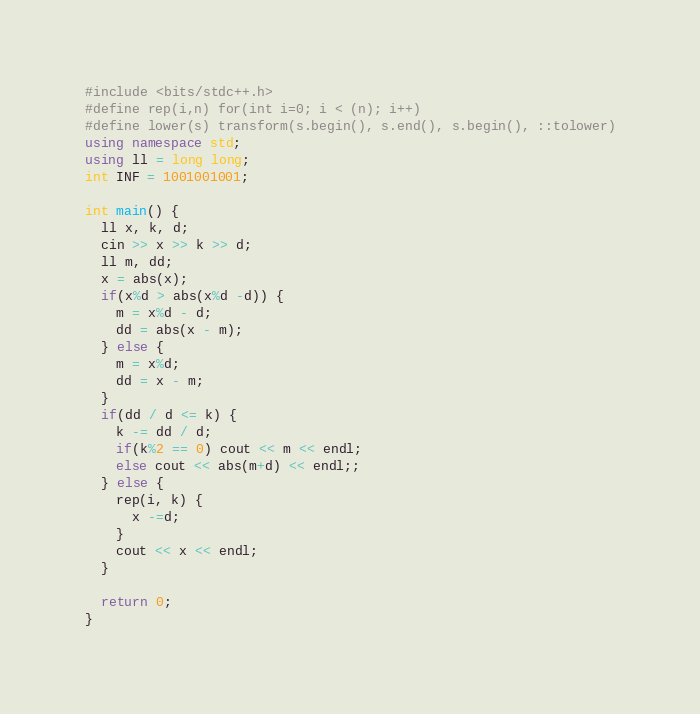Convert code to text. <code><loc_0><loc_0><loc_500><loc_500><_C++_>#include <bits/stdc++.h>
#define rep(i,n) for(int i=0; i < (n); i++)
#define lower(s) transform(s.begin(), s.end(), s.begin(), ::tolower)
using namespace std;
using ll = long long;
int INF = 1001001001;

int main() {
  ll x, k, d;
  cin >> x >> k >> d;
  ll m, dd;
  x = abs(x);
  if(x%d > abs(x%d -d)) {
    m = x%d - d;
    dd = abs(x - m);
  } else {
    m = x%d;
    dd = x - m;
  }
  if(dd / d <= k) {
    k -= dd / d;
    if(k%2 == 0) cout << m << endl;
    else cout << abs(m+d) << endl;;
  } else {
    rep(i, k) {
      x -=d;
    }
    cout << x << endl;
  }

  return 0;
}</code> 